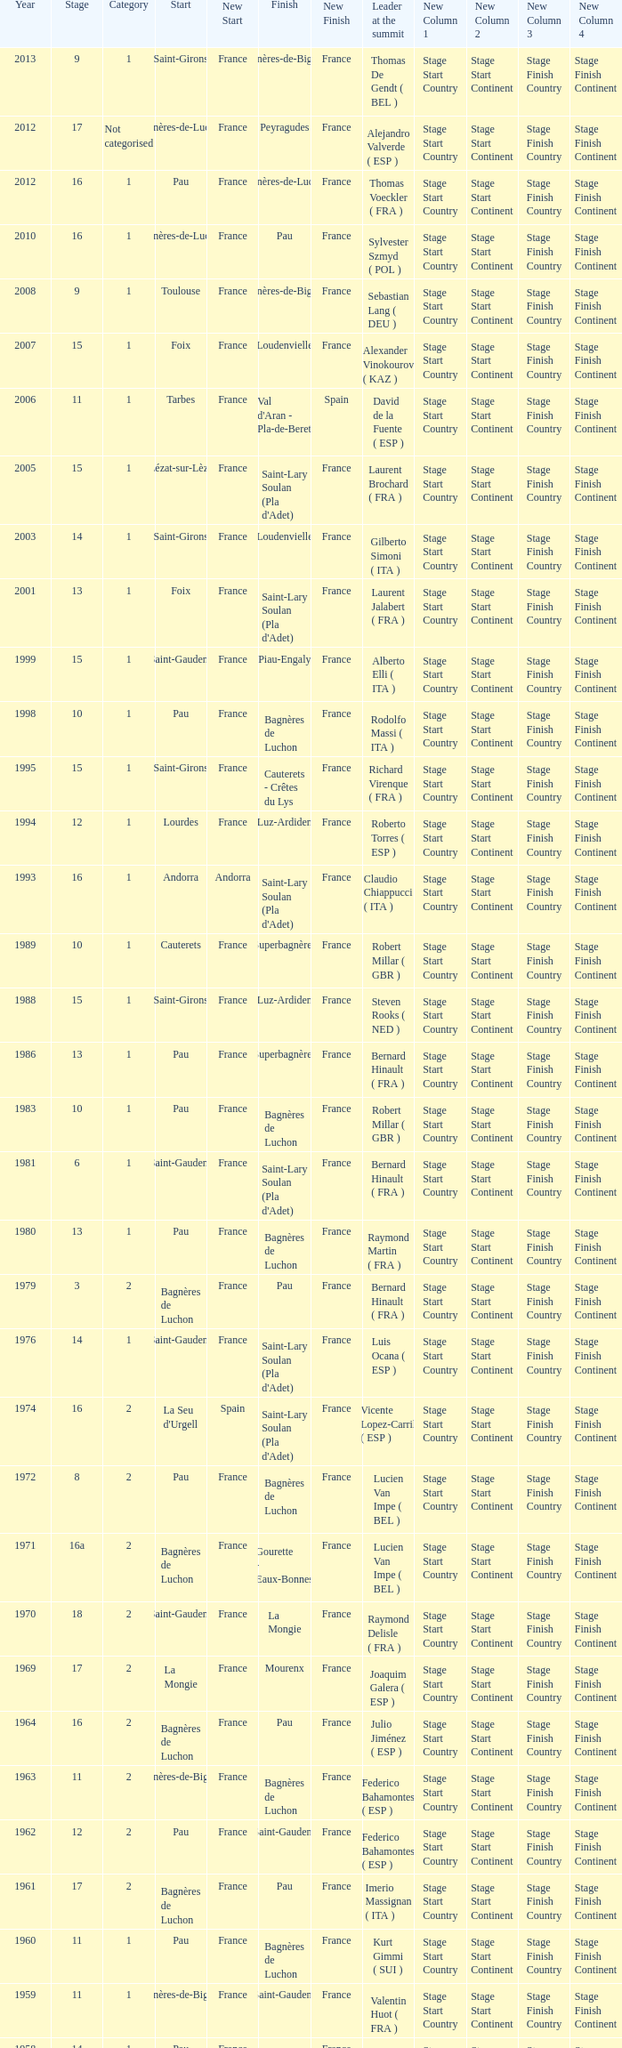What category was in 1964? 2.0. 